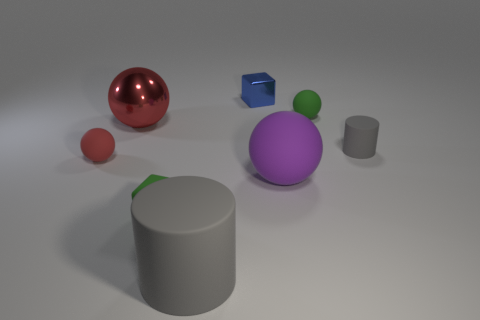There is a small ball that is left of the large gray matte thing; are there any small blocks in front of it?
Offer a very short reply. Yes. Is there a red rubber object that is left of the metallic thing behind the green thing behind the large red thing?
Provide a succinct answer. Yes. Is the shape of the small thing in front of the large purple rubber ball the same as the small metal object that is behind the big red shiny sphere?
Give a very brief answer. Yes. There is a small object that is made of the same material as the large red sphere; what color is it?
Keep it short and to the point. Blue. Are there fewer purple spheres that are in front of the rubber cube than large yellow cubes?
Make the answer very short. No. There is a gray rubber cylinder right of the cylinder that is left of the gray rubber thing on the right side of the small metal block; how big is it?
Keep it short and to the point. Small. Is the material of the cylinder that is to the left of the small shiny block the same as the small blue cube?
Your answer should be very brief. No. What number of objects are green matte objects or blue things?
Ensure brevity in your answer.  3. There is a green rubber object that is the same shape as the small metal thing; what size is it?
Your answer should be compact. Small. How many other things are the same color as the metal cube?
Give a very brief answer. 0. 